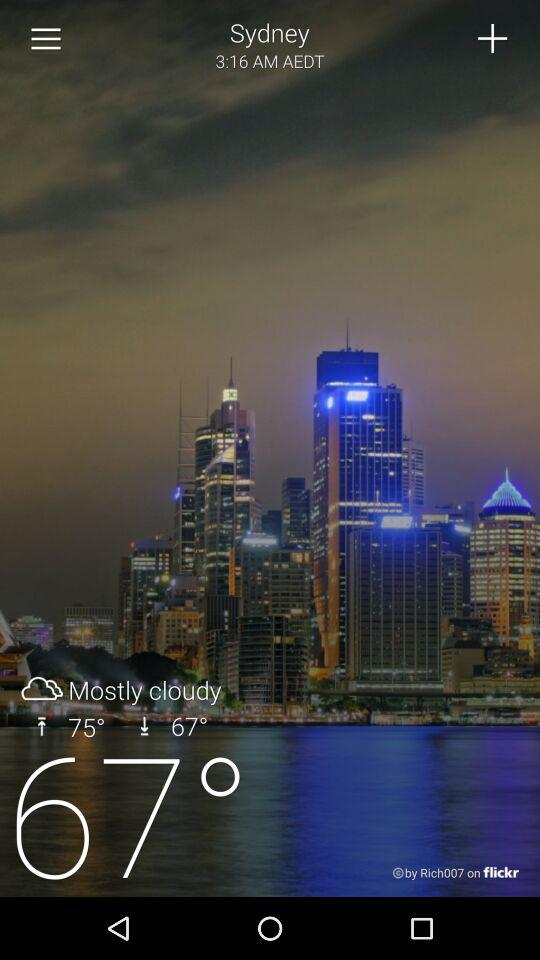What is the temperature in Sydney? The temperature is 67°. 